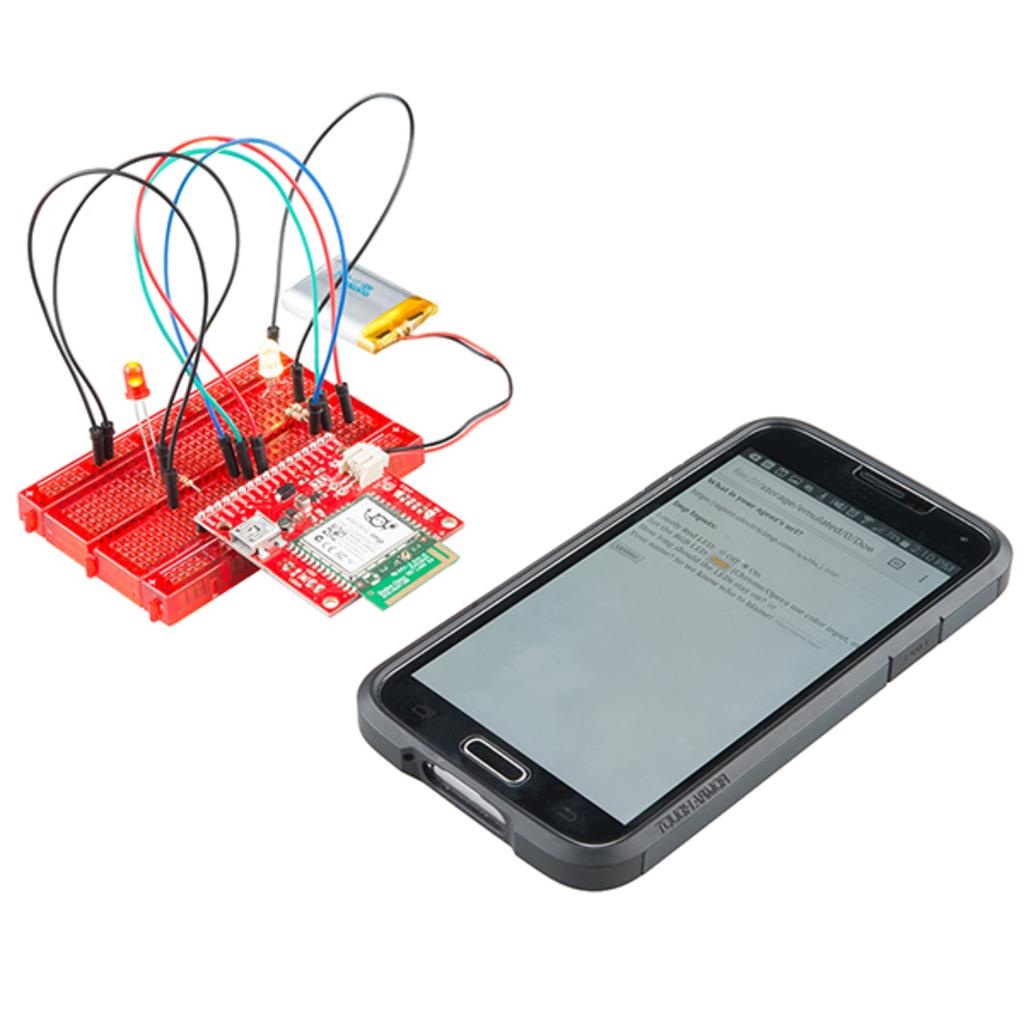What is the first word on the phone screen?
Your answer should be compact. What. 